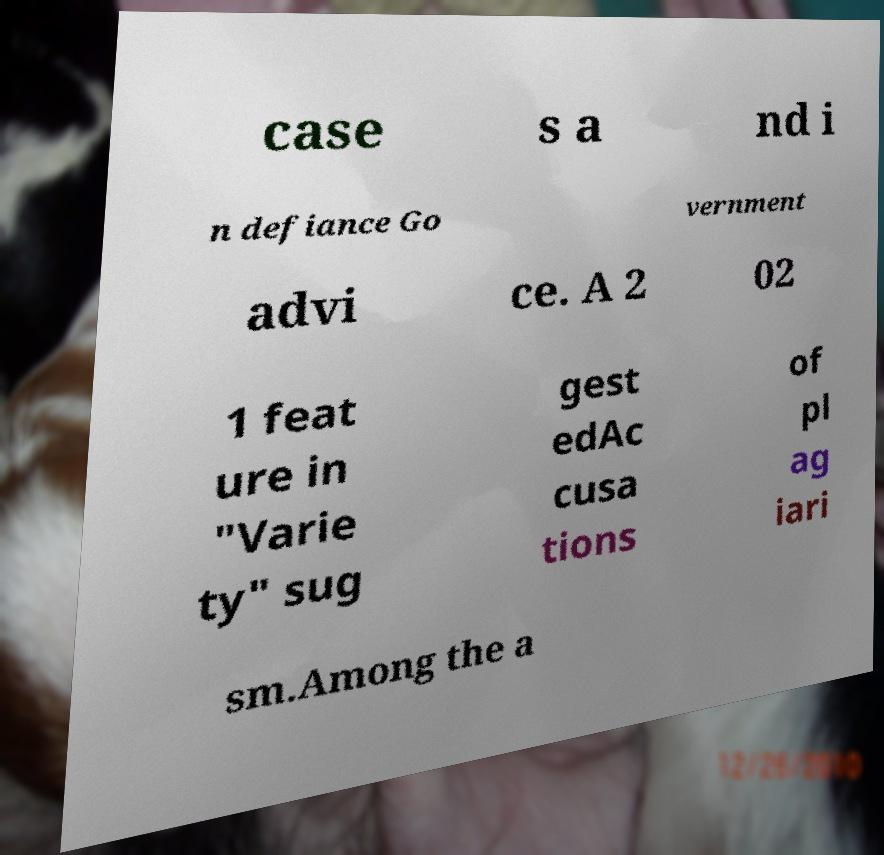Please identify and transcribe the text found in this image. case s a nd i n defiance Go vernment advi ce. A 2 02 1 feat ure in "Varie ty" sug gest edAc cusa tions of pl ag iari sm.Among the a 